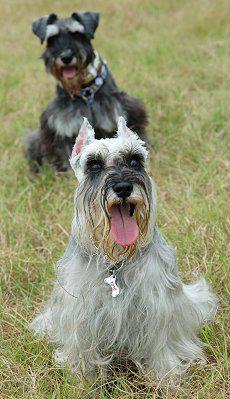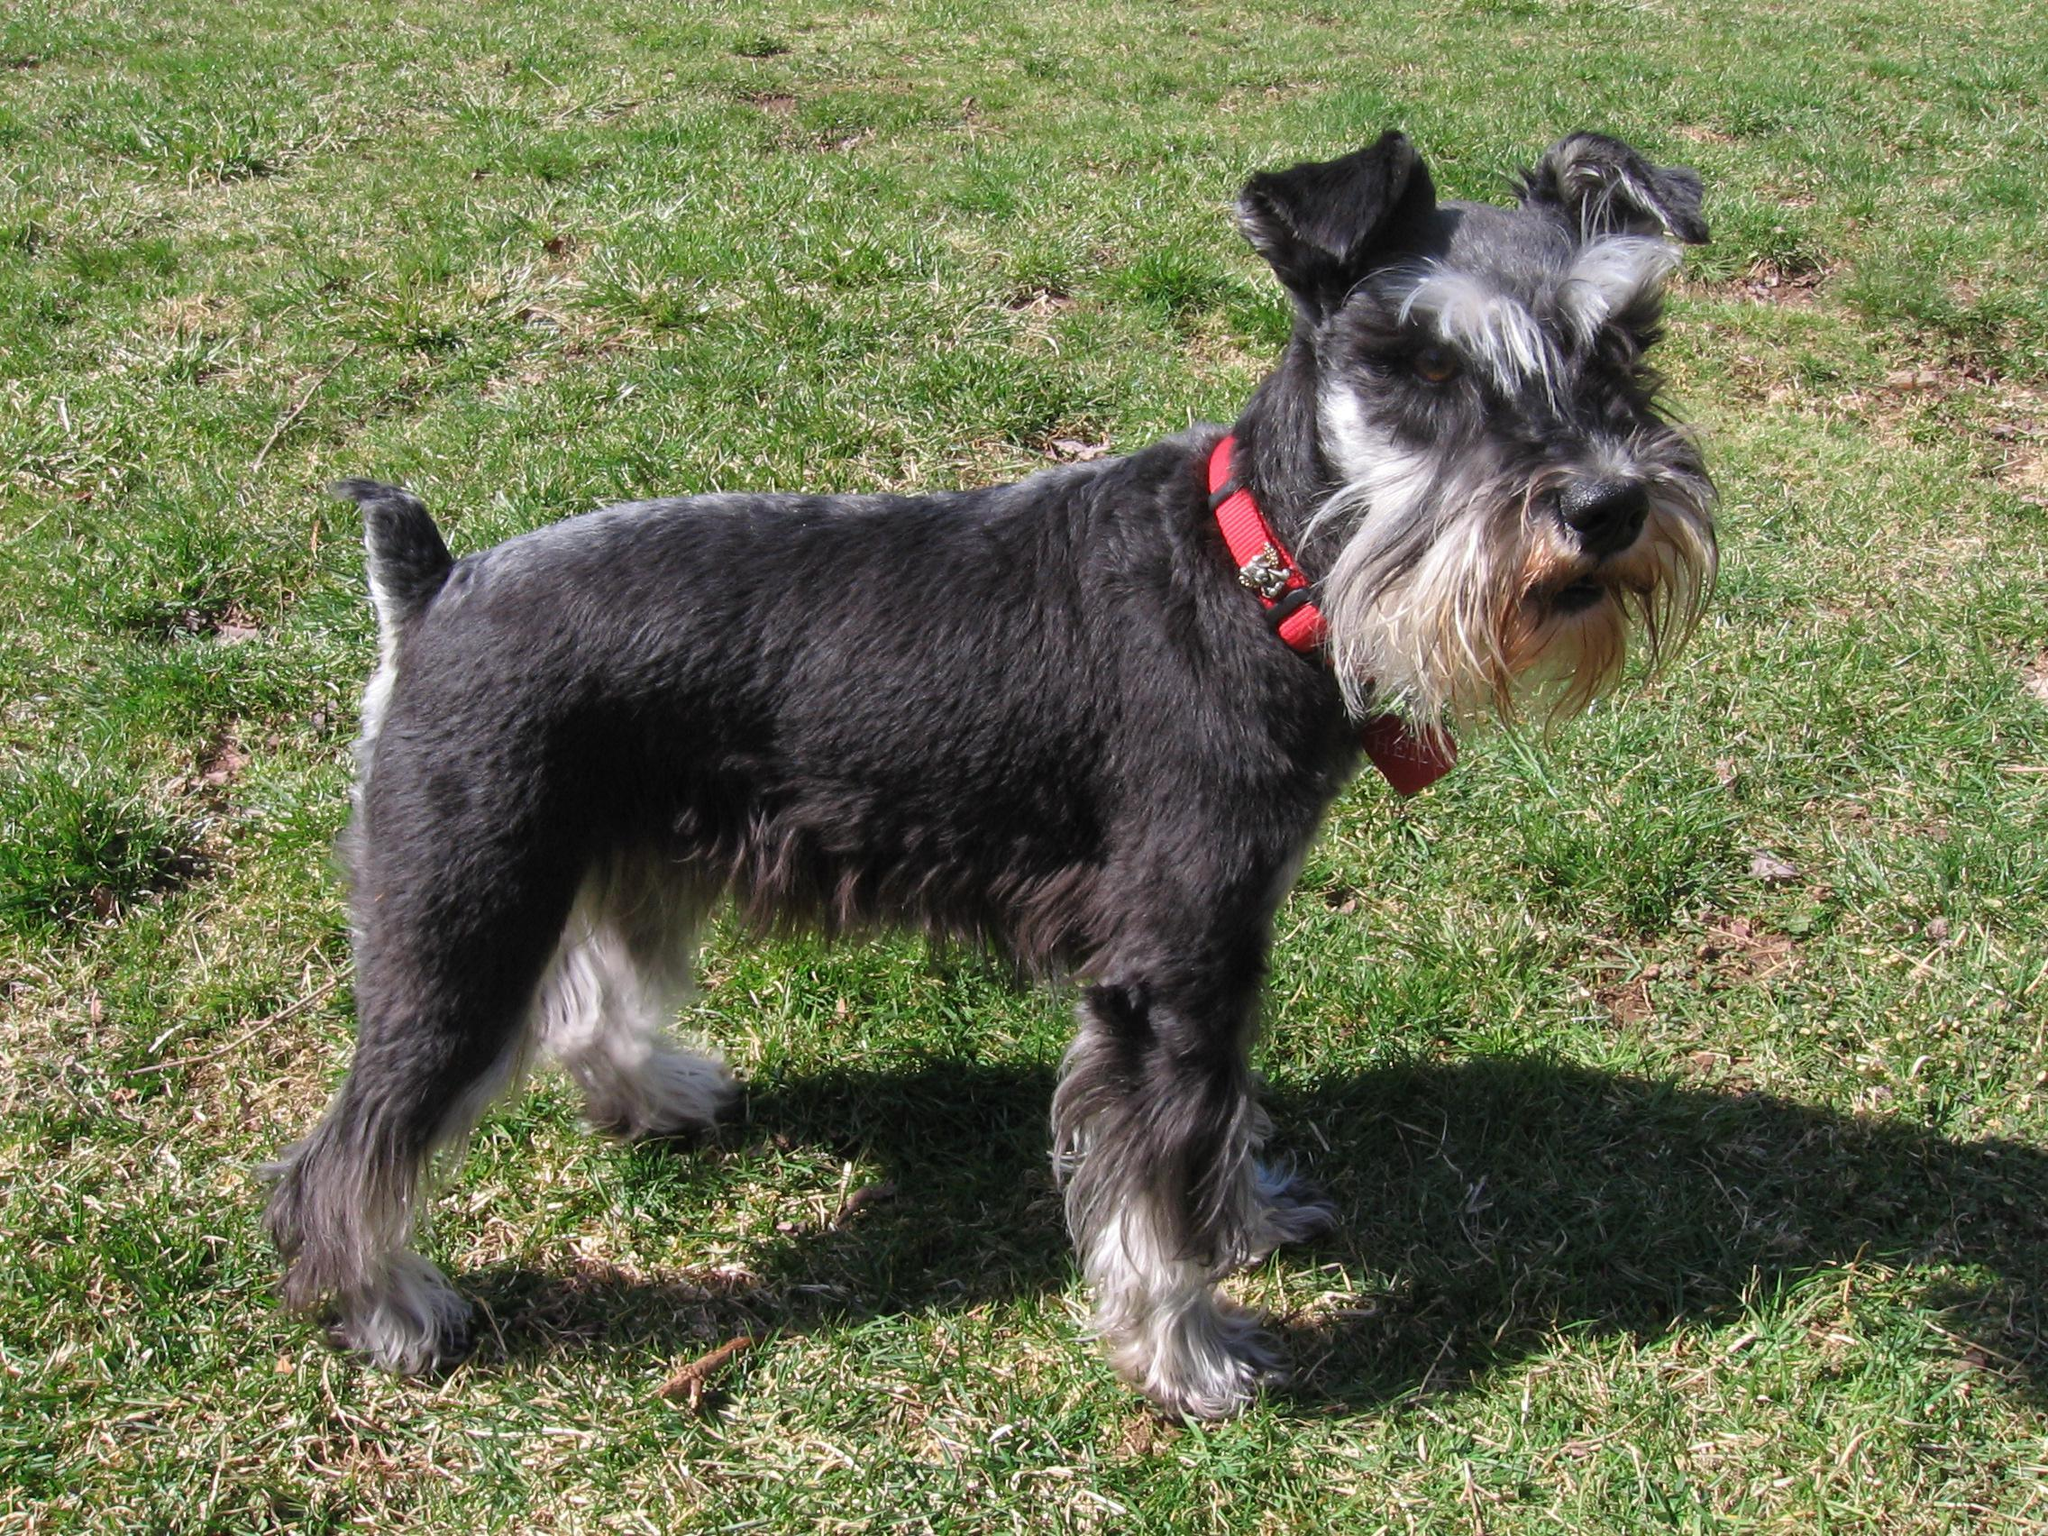The first image is the image on the left, the second image is the image on the right. Assess this claim about the two images: "One dog has pointy ears and two dogs have ears turned down.". Correct or not? Answer yes or no. Yes. The first image is the image on the left, the second image is the image on the right. Examine the images to the left and right. Is the description "One image shows two schnauzers on the grass." accurate? Answer yes or no. Yes. 